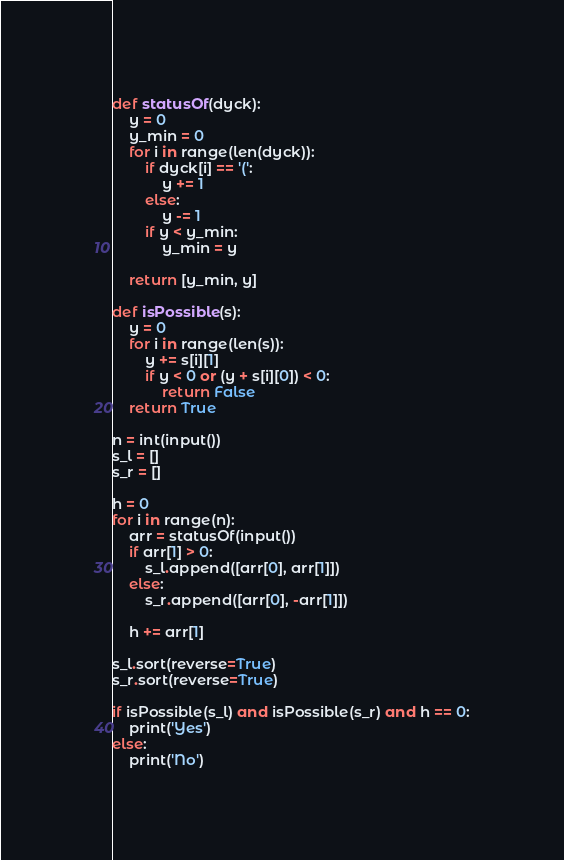Convert code to text. <code><loc_0><loc_0><loc_500><loc_500><_Python_>def statusOf(dyck):
    y = 0
    y_min = 0
    for i in range(len(dyck)):
        if dyck[i] == '(':
            y += 1
        else:
            y -= 1
        if y < y_min:
            y_min = y
    
    return [y_min, y]

def isPossible(s):
    y = 0
    for i in range(len(s)):
        y += s[i][1]
        if y < 0 or (y + s[i][0]) < 0:
            return False
    return True

n = int(input())
s_l = []
s_r = []

h = 0
for i in range(n):
    arr = statusOf(input())
    if arr[1] > 0:
        s_l.append([arr[0], arr[1]])
    else:
        s_r.append([arr[0], -arr[1]])
    
    h += arr[1]

s_l.sort(reverse=True)
s_r.sort(reverse=True)

if isPossible(s_l) and isPossible(s_r) and h == 0:
    print('Yes')
else:
    print('No')</code> 